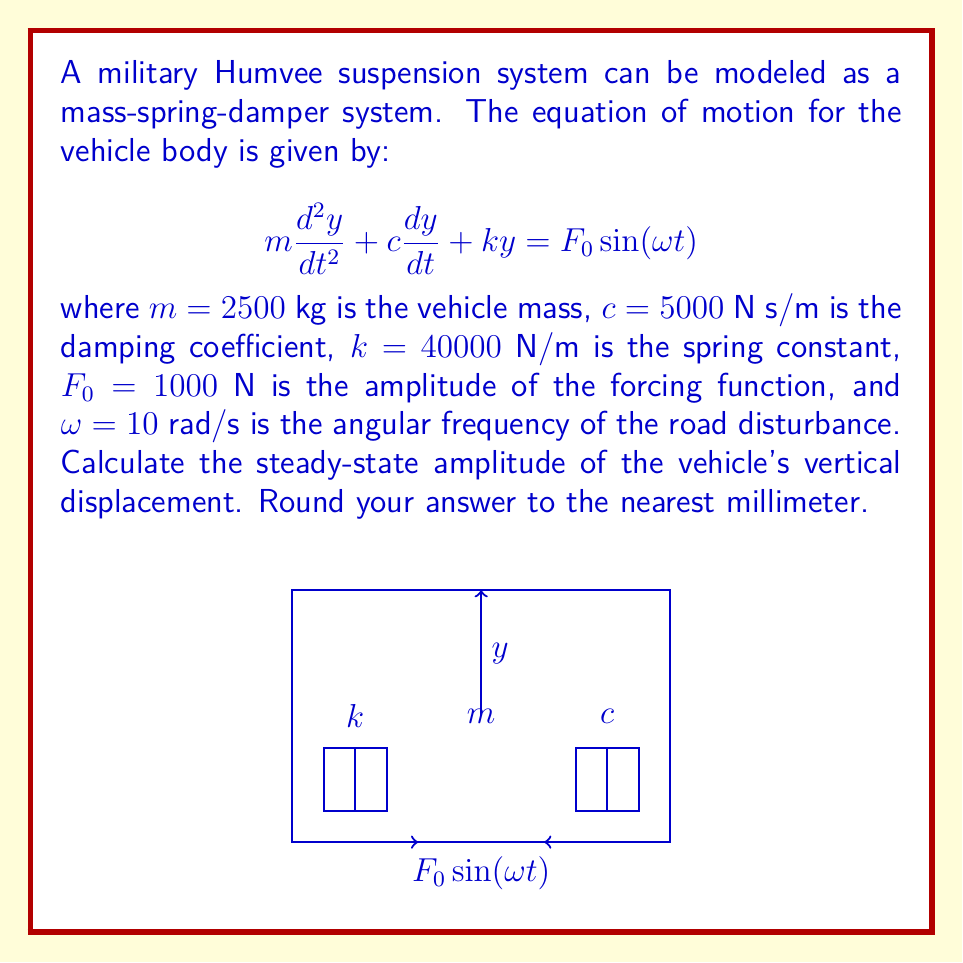Can you solve this math problem? To solve this problem, we'll follow these steps:

1) The steady-state solution for a forced vibration system has the form:

   $$y(t) = Y\sin(\omega t - \phi)$$

   where $Y$ is the amplitude we're looking for.

2) For a system described by the given differential equation, the amplitude $Y$ is given by:

   $$Y = \frac{F_0}{\sqrt{(k-m\omega^2)^2 + (c\omega)^2}}$$

3) Let's substitute the given values:
   
   $m = 2500$ kg
   $c = 5000$ N⋅s/m
   $k = 40000$ N/m
   $F_0 = 1000$ N
   $\omega = 10$ rad/s

4) First, calculate $k-m\omega^2$:
   
   $$k-m\omega^2 = 40000 - 2500(10)^2 = -210000$$

5) Next, calculate $c\omega$:
   
   $$c\omega = 5000(10) = 50000$$

6) Now we can calculate the denominator:

   $$\sqrt{(-210000)^2 + (50000)^2} = \sqrt{44100000000 + 2500000000} = \sqrt{46600000000} = 215870$$

7) Finally, we can calculate $Y$:

   $$Y = \frac{1000}{215870} \approx 0.00463 \text{ m} = 4.63 \text{ mm}$$

8) Rounding to the nearest millimeter gives us 5 mm.
Answer: 5 mm 